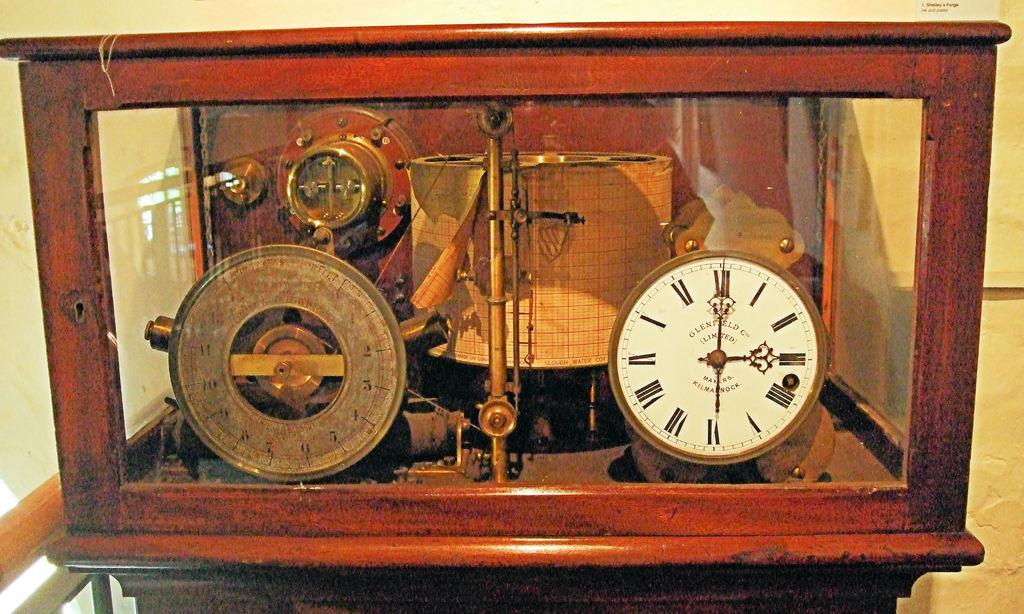Provide a one-sentence caption for the provided image. An old fashioned clock in a wooden and glass box with watch face that says "Olenfield Co Limited.". 